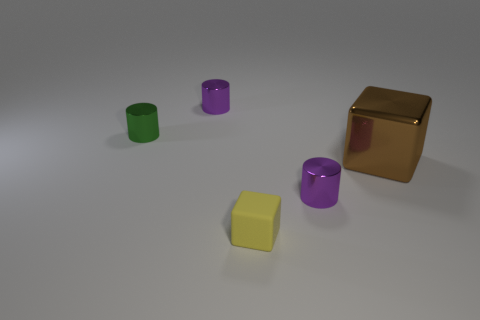Subtract all purple cylinders. How many cylinders are left? 1 Add 4 purple objects. How many objects exist? 9 Subtract 2 cylinders. How many cylinders are left? 1 Add 3 large shiny blocks. How many large shiny blocks are left? 4 Add 1 small purple metallic cylinders. How many small purple metallic cylinders exist? 3 Subtract all yellow blocks. How many blocks are left? 1 Subtract 0 blue balls. How many objects are left? 5 Subtract all cylinders. How many objects are left? 2 Subtract all blue cylinders. Subtract all purple balls. How many cylinders are left? 3 Subtract all gray spheres. How many green cylinders are left? 1 